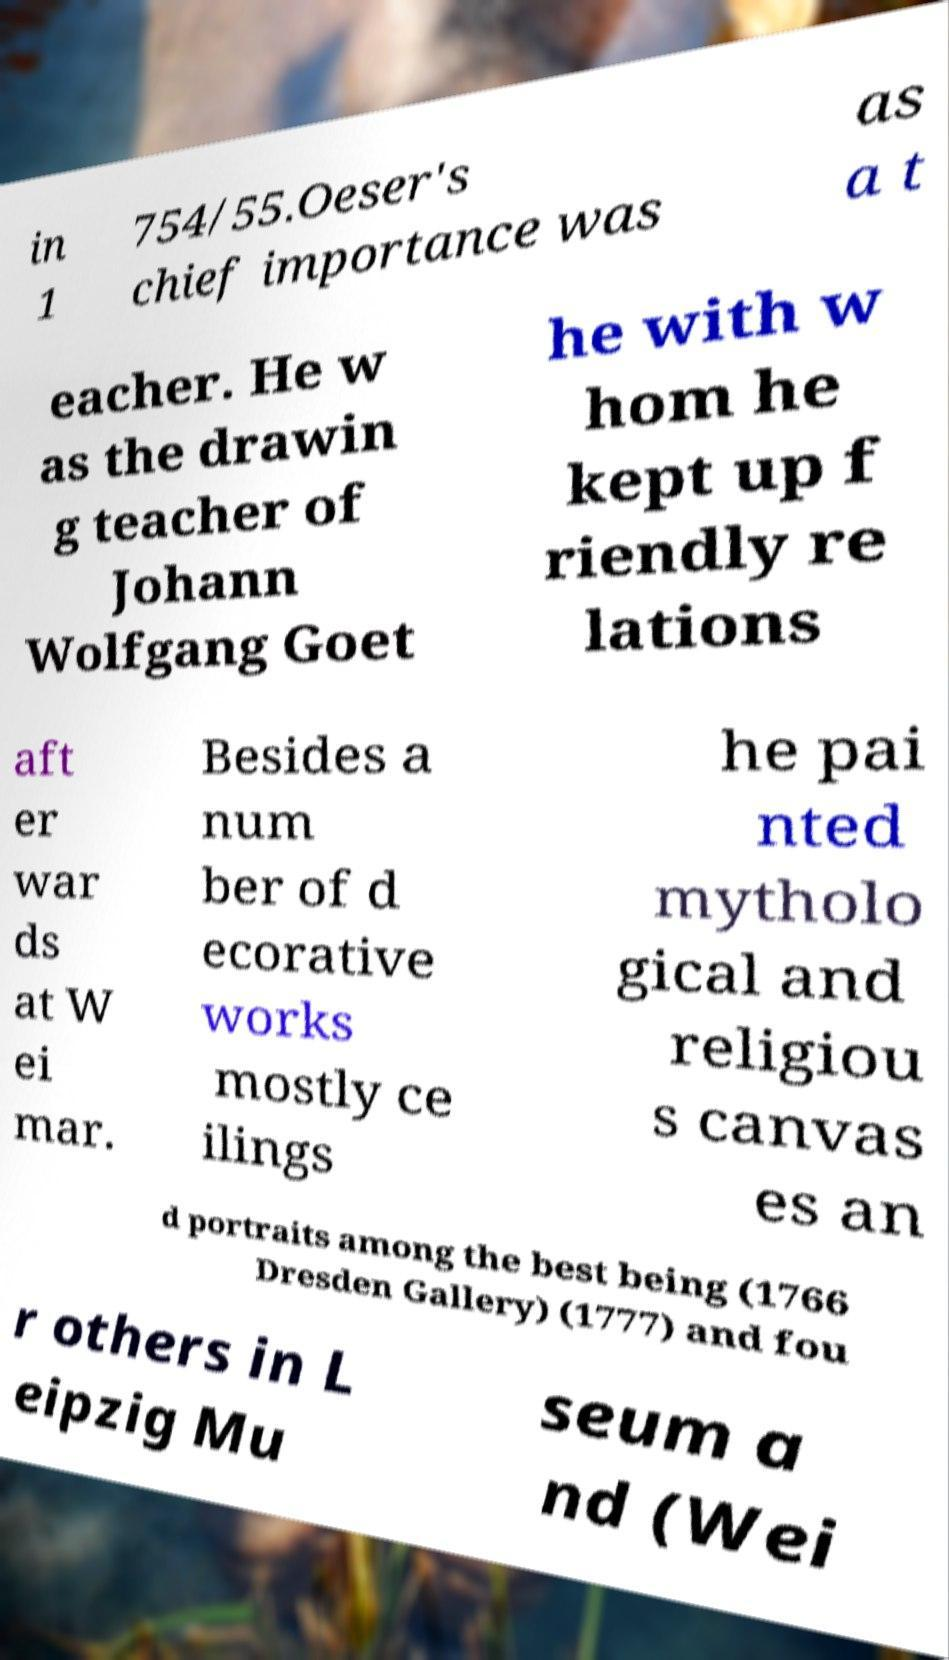Please read and relay the text visible in this image. What does it say? in 1 754/55.Oeser's chief importance was as a t eacher. He w as the drawin g teacher of Johann Wolfgang Goet he with w hom he kept up f riendly re lations aft er war ds at W ei mar. Besides a num ber of d ecorative works mostly ce ilings he pai nted mytholo gical and religiou s canvas es an d portraits among the best being (1766 Dresden Gallery) (1777) and fou r others in L eipzig Mu seum a nd (Wei 